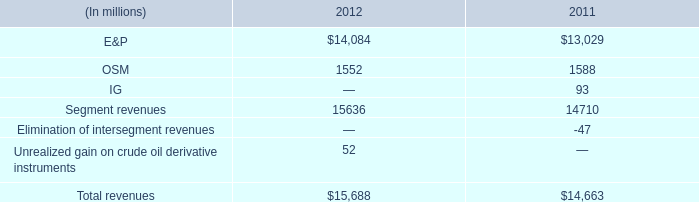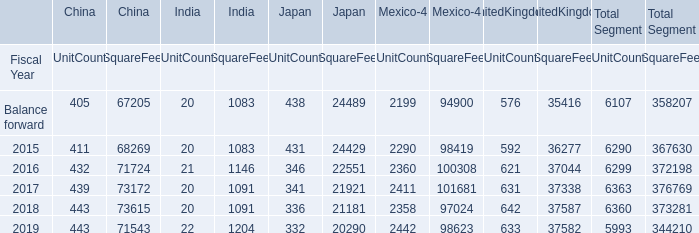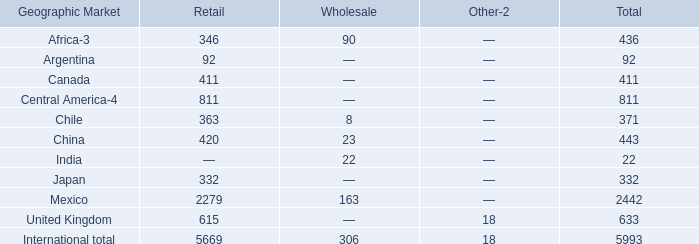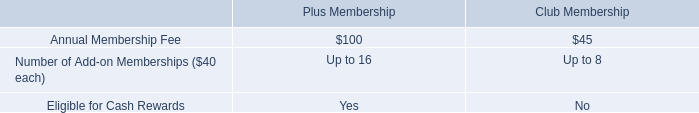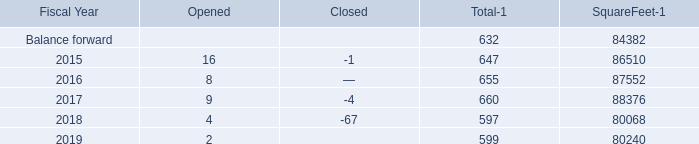What's the total value of all Wholesale that are in the range of 0 and 30 for Wholesale? 
Computations: ((8 + 22) + 23)
Answer: 53.0. 